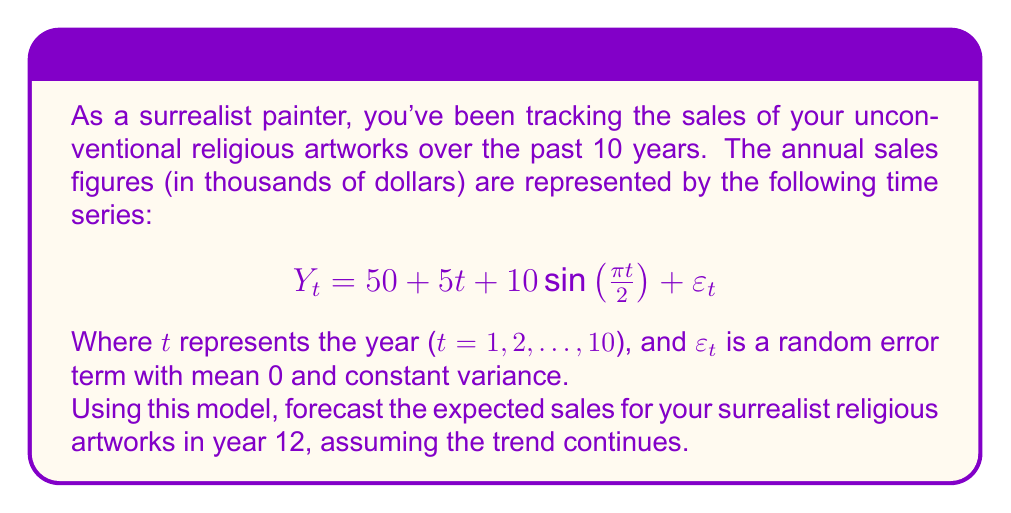Provide a solution to this math problem. To forecast the expected sales for year 12, we need to follow these steps:

1) Identify the components of the time series model:
   - Trend component: $50 + 5t$
   - Seasonal component: $10 \sin(\frac{\pi t}{2})$
   - Random error: $\varepsilon_t$

2) For the forecast, we ignore the random error term as its expected value is 0.

3) Substitute t = 12 into the model:

   $$Y_{12} = 50 + 5(12) + 10 \sin(\frac{\pi (12)}{2})$$

4) Calculate the trend component:
   $50 + 5(12) = 50 + 60 = 110$

5) Calculate the seasonal component:
   $10 \sin(\frac{\pi (12)}{2}) = 10 \sin(6\pi) = 0$
   (Note: $\sin(6\pi) = 0$ because sine has a period of $2\pi$)

6) Sum the components:
   $Y_{12} = 110 + 0 = 110$

Therefore, the expected sales for year 12 would be 110 thousand dollars.
Answer: $110,000 